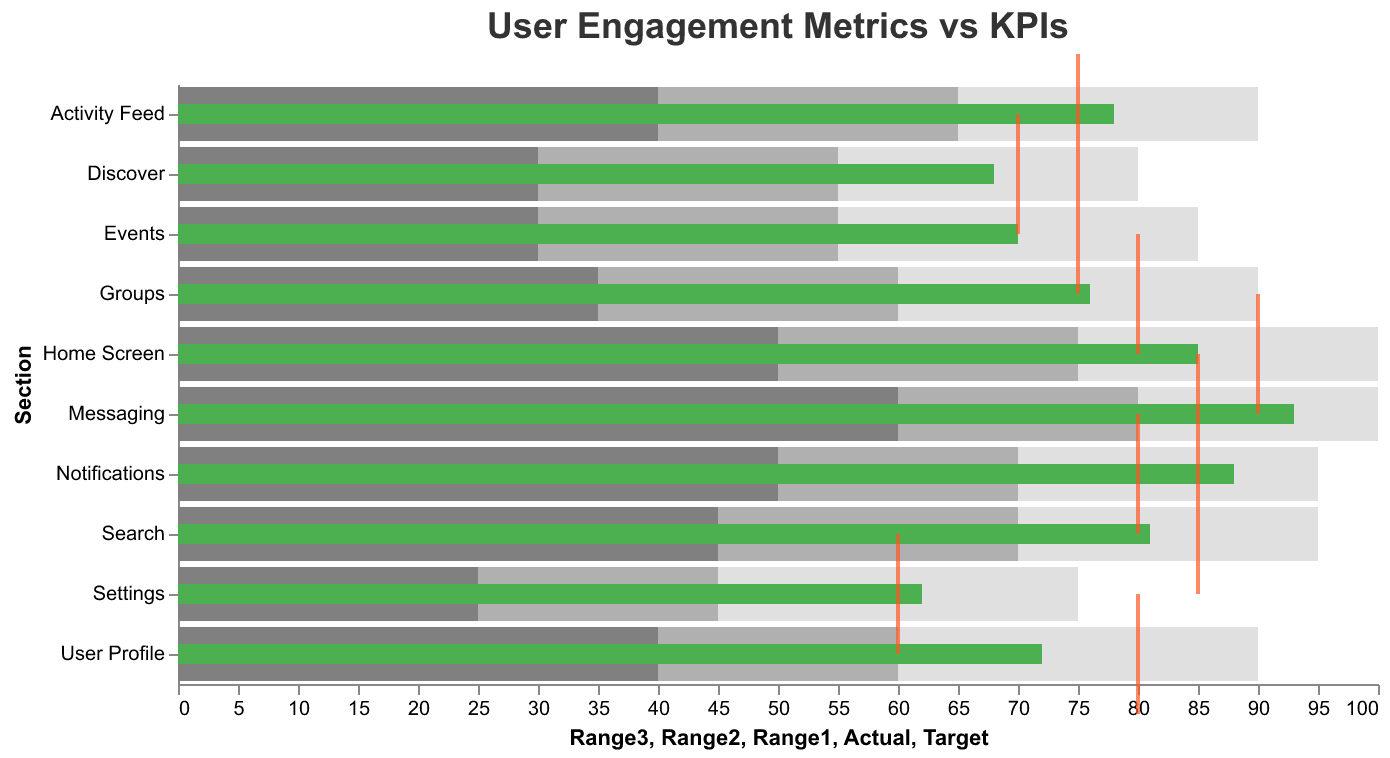What is the title of the figure? The title is typically found at the top and provides a summary of what the figure demonstrates. Here, the title "User Engagement Metrics vs KPIs" is shown.
Answer: User Engagement Metrics vs KPIs Which section has the highest actual user engagement? The actual user engagement is represented by the green bar. The "Messaging" section has the highest actual value of 93.
Answer: Messaging What is the target engagement for the Home Screen section? The target engagement is marked by the orange tick. For the "Home Screen" section, this tick is positioned at 90.
Answer: 90 How many sections have their actual engagement value equal to or greater than their target? Compare the green bars (actual engagement) to the orange ticks (targets). If the green bar extends to or beyond the orange tick, that section meets or exceeds its target. Sections are "Messaging," "Activity Feed," "Settings," and "Notifications".
Answer: 4 What is the difference between actual and target engagements for the Discover section? Subtract the target value from the actual value for the "Discover" section. The actual is 68 and the target is 70, thus 68 - 70 = -2.
Answer: -2 Which section has the lowest target engagement? The lowest target engagement is shown by the position of the orange ticks. "Settings" has the lowest target engagement with a value of 60.
Answer: Settings Which sections fall in the poor engagement range (Range1) based on actual values? Poor engagement range (Range1) is shown in the darkest gray area. Sections where the actual value (green bar) falls into this range are "User Profile," "Discover," "Settings," and "Events."
Answer: User Profile, Discover, Settings, Events Does the "Search" section meet the target engagement? The green bar (actual engagement) does not extend to the orange tick (target). For "Search," the target is 85 and the actual is 81, so it falls short.
Answer: No Which section has the closest actual engagement to its target? Calculate the difference between the actual and target engagements for each section. The "Activity Feed" section has the smallest difference with an actual of 78 and a target of 75.
Answer: Activity Feed 